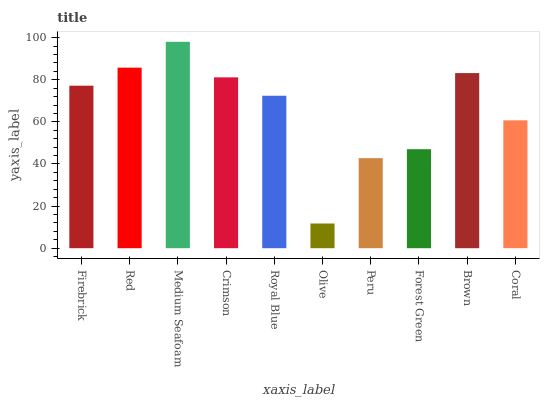Is Olive the minimum?
Answer yes or no. Yes. Is Medium Seafoam the maximum?
Answer yes or no. Yes. Is Red the minimum?
Answer yes or no. No. Is Red the maximum?
Answer yes or no. No. Is Red greater than Firebrick?
Answer yes or no. Yes. Is Firebrick less than Red?
Answer yes or no. Yes. Is Firebrick greater than Red?
Answer yes or no. No. Is Red less than Firebrick?
Answer yes or no. No. Is Firebrick the high median?
Answer yes or no. Yes. Is Royal Blue the low median?
Answer yes or no. Yes. Is Crimson the high median?
Answer yes or no. No. Is Olive the low median?
Answer yes or no. No. 